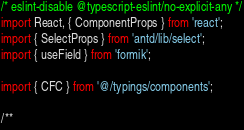<code> <loc_0><loc_0><loc_500><loc_500><_TypeScript_>/* eslint-disable @typescript-eslint/no-explicit-any */
import React, { ComponentProps } from 'react';
import { SelectProps } from 'antd/lib/select';
import { useField } from 'formik';

import { CFC } from '@/typings/components';

/**</code> 